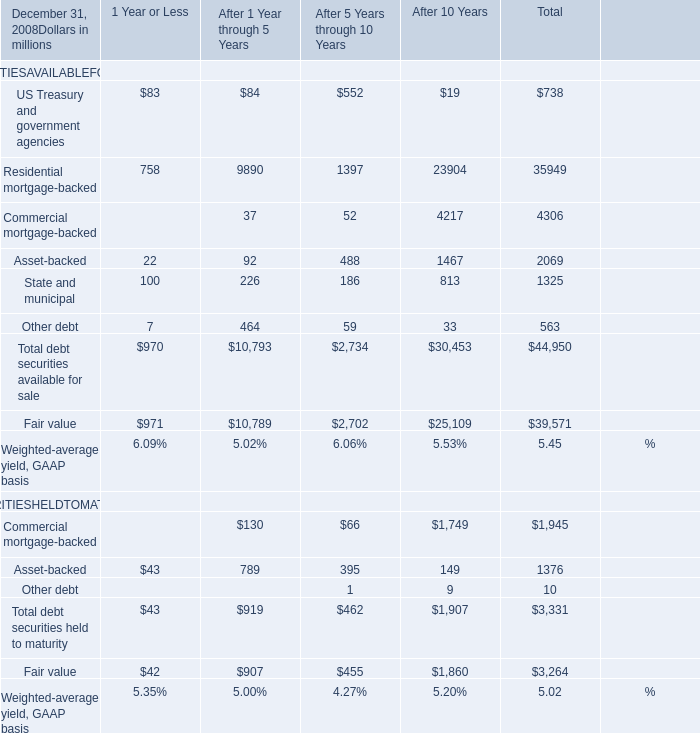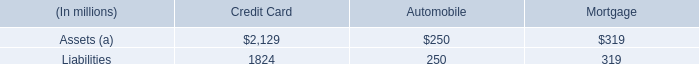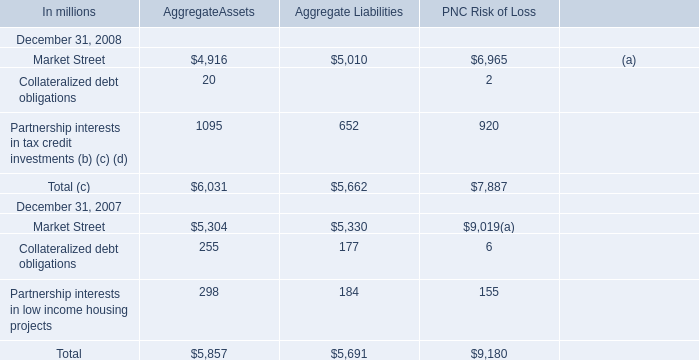What's the sum of Market Street of PNC Risk of Loss, Fair value of After 1 Year through 5 Years, and Total debt securities held to maturity SECURITIESHELDTOMATURITY of After 10 Years ? 
Computations: ((6965.0 + 10789.0) + 1907.0)
Answer: 19661.0. 